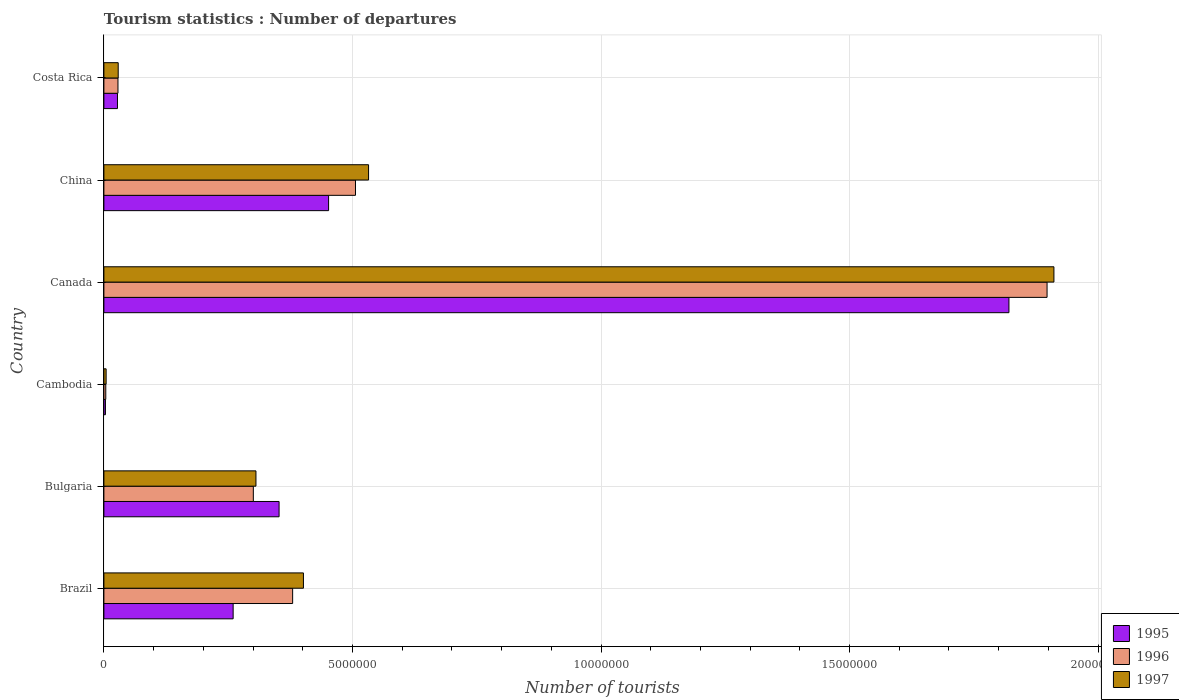How many bars are there on the 6th tick from the bottom?
Your answer should be compact. 3. What is the label of the 6th group of bars from the top?
Your answer should be very brief. Brazil. What is the number of tourist departures in 1995 in China?
Provide a succinct answer. 4.52e+06. Across all countries, what is the maximum number of tourist departures in 1996?
Give a very brief answer. 1.90e+07. Across all countries, what is the minimum number of tourist departures in 1996?
Your answer should be compact. 3.80e+04. In which country was the number of tourist departures in 1997 minimum?
Provide a succinct answer. Cambodia. What is the total number of tourist departures in 1995 in the graph?
Your answer should be very brief. 2.92e+07. What is the difference between the number of tourist departures in 1997 in Bulgaria and that in Cambodia?
Make the answer very short. 3.01e+06. What is the difference between the number of tourist departures in 1997 in Brazil and the number of tourist departures in 1996 in Bulgaria?
Offer a very short reply. 1.01e+06. What is the average number of tourist departures in 1995 per country?
Your answer should be very brief. 4.86e+06. What is the difference between the number of tourist departures in 1997 and number of tourist departures in 1996 in Cambodia?
Provide a short and direct response. 7000. What is the ratio of the number of tourist departures in 1996 in Brazil to that in Canada?
Your answer should be very brief. 0.2. Is the number of tourist departures in 1995 in Brazil less than that in Costa Rica?
Provide a succinct answer. No. What is the difference between the highest and the second highest number of tourist departures in 1997?
Give a very brief answer. 1.38e+07. What is the difference between the highest and the lowest number of tourist departures in 1997?
Your response must be concise. 1.91e+07. Is the sum of the number of tourist departures in 1995 in China and Costa Rica greater than the maximum number of tourist departures in 1997 across all countries?
Make the answer very short. No. What does the 3rd bar from the top in Brazil represents?
Make the answer very short. 1995. What does the 2nd bar from the bottom in Brazil represents?
Your answer should be very brief. 1996. Is it the case that in every country, the sum of the number of tourist departures in 1996 and number of tourist departures in 1995 is greater than the number of tourist departures in 1997?
Make the answer very short. Yes. How many bars are there?
Provide a short and direct response. 18. How many countries are there in the graph?
Provide a succinct answer. 6. What is the difference between two consecutive major ticks on the X-axis?
Provide a succinct answer. 5.00e+06. Are the values on the major ticks of X-axis written in scientific E-notation?
Keep it short and to the point. No. Does the graph contain any zero values?
Your answer should be compact. No. How many legend labels are there?
Keep it short and to the point. 3. What is the title of the graph?
Offer a terse response. Tourism statistics : Number of departures. What is the label or title of the X-axis?
Provide a short and direct response. Number of tourists. What is the label or title of the Y-axis?
Ensure brevity in your answer.  Country. What is the Number of tourists in 1995 in Brazil?
Keep it short and to the point. 2.60e+06. What is the Number of tourists of 1996 in Brazil?
Offer a terse response. 3.80e+06. What is the Number of tourists in 1997 in Brazil?
Your answer should be compact. 4.01e+06. What is the Number of tourists in 1995 in Bulgaria?
Your answer should be very brief. 3.52e+06. What is the Number of tourists of 1996 in Bulgaria?
Ensure brevity in your answer.  3.01e+06. What is the Number of tourists in 1997 in Bulgaria?
Offer a very short reply. 3.06e+06. What is the Number of tourists of 1995 in Cambodia?
Provide a short and direct response. 3.10e+04. What is the Number of tourists of 1996 in Cambodia?
Your answer should be compact. 3.80e+04. What is the Number of tourists in 1997 in Cambodia?
Your answer should be compact. 4.50e+04. What is the Number of tourists of 1995 in Canada?
Offer a very short reply. 1.82e+07. What is the Number of tourists in 1996 in Canada?
Your answer should be compact. 1.90e+07. What is the Number of tourists in 1997 in Canada?
Your answer should be compact. 1.91e+07. What is the Number of tourists of 1995 in China?
Your response must be concise. 4.52e+06. What is the Number of tourists of 1996 in China?
Provide a succinct answer. 5.06e+06. What is the Number of tourists in 1997 in China?
Provide a short and direct response. 5.32e+06. What is the Number of tourists in 1995 in Costa Rica?
Provide a short and direct response. 2.73e+05. What is the Number of tourists of 1996 in Costa Rica?
Your answer should be very brief. 2.83e+05. What is the Number of tourists of 1997 in Costa Rica?
Your response must be concise. 2.88e+05. Across all countries, what is the maximum Number of tourists of 1995?
Ensure brevity in your answer.  1.82e+07. Across all countries, what is the maximum Number of tourists of 1996?
Offer a terse response. 1.90e+07. Across all countries, what is the maximum Number of tourists of 1997?
Keep it short and to the point. 1.91e+07. Across all countries, what is the minimum Number of tourists of 1995?
Give a very brief answer. 3.10e+04. Across all countries, what is the minimum Number of tourists in 1996?
Your answer should be compact. 3.80e+04. Across all countries, what is the minimum Number of tourists of 1997?
Your answer should be compact. 4.50e+04. What is the total Number of tourists in 1995 in the graph?
Make the answer very short. 2.92e+07. What is the total Number of tourists of 1996 in the graph?
Offer a very short reply. 3.12e+07. What is the total Number of tourists of 1997 in the graph?
Ensure brevity in your answer.  3.18e+07. What is the difference between the Number of tourists of 1995 in Brazil and that in Bulgaria?
Offer a very short reply. -9.24e+05. What is the difference between the Number of tourists of 1996 in Brazil and that in Bulgaria?
Offer a terse response. 7.91e+05. What is the difference between the Number of tourists of 1997 in Brazil and that in Bulgaria?
Your answer should be compact. 9.55e+05. What is the difference between the Number of tourists of 1995 in Brazil and that in Cambodia?
Your response must be concise. 2.57e+06. What is the difference between the Number of tourists of 1996 in Brazil and that in Cambodia?
Offer a terse response. 3.76e+06. What is the difference between the Number of tourists in 1997 in Brazil and that in Cambodia?
Provide a short and direct response. 3.97e+06. What is the difference between the Number of tourists in 1995 in Brazil and that in Canada?
Give a very brief answer. -1.56e+07. What is the difference between the Number of tourists in 1996 in Brazil and that in Canada?
Make the answer very short. -1.52e+07. What is the difference between the Number of tourists in 1997 in Brazil and that in Canada?
Your answer should be compact. -1.51e+07. What is the difference between the Number of tourists of 1995 in Brazil and that in China?
Your response must be concise. -1.92e+06. What is the difference between the Number of tourists in 1996 in Brazil and that in China?
Your answer should be very brief. -1.26e+06. What is the difference between the Number of tourists in 1997 in Brazil and that in China?
Offer a very short reply. -1.31e+06. What is the difference between the Number of tourists of 1995 in Brazil and that in Costa Rica?
Keep it short and to the point. 2.33e+06. What is the difference between the Number of tourists in 1996 in Brazil and that in Costa Rica?
Your answer should be compact. 3.51e+06. What is the difference between the Number of tourists in 1997 in Brazil and that in Costa Rica?
Ensure brevity in your answer.  3.73e+06. What is the difference between the Number of tourists of 1995 in Bulgaria and that in Cambodia?
Offer a terse response. 3.49e+06. What is the difference between the Number of tourists of 1996 in Bulgaria and that in Cambodia?
Give a very brief answer. 2.97e+06. What is the difference between the Number of tourists in 1997 in Bulgaria and that in Cambodia?
Your answer should be very brief. 3.01e+06. What is the difference between the Number of tourists of 1995 in Bulgaria and that in Canada?
Provide a succinct answer. -1.47e+07. What is the difference between the Number of tourists of 1996 in Bulgaria and that in Canada?
Your answer should be very brief. -1.60e+07. What is the difference between the Number of tourists in 1997 in Bulgaria and that in Canada?
Your answer should be compact. -1.61e+07. What is the difference between the Number of tourists in 1995 in Bulgaria and that in China?
Keep it short and to the point. -9.96e+05. What is the difference between the Number of tourists in 1996 in Bulgaria and that in China?
Your answer should be very brief. -2.06e+06. What is the difference between the Number of tourists in 1997 in Bulgaria and that in China?
Keep it short and to the point. -2.26e+06. What is the difference between the Number of tourists of 1995 in Bulgaria and that in Costa Rica?
Give a very brief answer. 3.25e+06. What is the difference between the Number of tourists in 1996 in Bulgaria and that in Costa Rica?
Make the answer very short. 2.72e+06. What is the difference between the Number of tourists of 1997 in Bulgaria and that in Costa Rica?
Your answer should be compact. 2.77e+06. What is the difference between the Number of tourists of 1995 in Cambodia and that in Canada?
Provide a short and direct response. -1.82e+07. What is the difference between the Number of tourists of 1996 in Cambodia and that in Canada?
Provide a succinct answer. -1.89e+07. What is the difference between the Number of tourists of 1997 in Cambodia and that in Canada?
Provide a succinct answer. -1.91e+07. What is the difference between the Number of tourists in 1995 in Cambodia and that in China?
Your answer should be compact. -4.49e+06. What is the difference between the Number of tourists of 1996 in Cambodia and that in China?
Keep it short and to the point. -5.02e+06. What is the difference between the Number of tourists of 1997 in Cambodia and that in China?
Offer a very short reply. -5.28e+06. What is the difference between the Number of tourists of 1995 in Cambodia and that in Costa Rica?
Provide a succinct answer. -2.42e+05. What is the difference between the Number of tourists of 1996 in Cambodia and that in Costa Rica?
Keep it short and to the point. -2.45e+05. What is the difference between the Number of tourists in 1997 in Cambodia and that in Costa Rica?
Offer a very short reply. -2.43e+05. What is the difference between the Number of tourists in 1995 in Canada and that in China?
Provide a short and direct response. 1.37e+07. What is the difference between the Number of tourists in 1996 in Canada and that in China?
Give a very brief answer. 1.39e+07. What is the difference between the Number of tourists of 1997 in Canada and that in China?
Provide a succinct answer. 1.38e+07. What is the difference between the Number of tourists in 1995 in Canada and that in Costa Rica?
Your answer should be very brief. 1.79e+07. What is the difference between the Number of tourists in 1996 in Canada and that in Costa Rica?
Your response must be concise. 1.87e+07. What is the difference between the Number of tourists in 1997 in Canada and that in Costa Rica?
Make the answer very short. 1.88e+07. What is the difference between the Number of tourists in 1995 in China and that in Costa Rica?
Offer a terse response. 4.25e+06. What is the difference between the Number of tourists of 1996 in China and that in Costa Rica?
Offer a very short reply. 4.78e+06. What is the difference between the Number of tourists of 1997 in China and that in Costa Rica?
Your response must be concise. 5.04e+06. What is the difference between the Number of tourists of 1995 in Brazil and the Number of tourists of 1996 in Bulgaria?
Give a very brief answer. -4.06e+05. What is the difference between the Number of tourists of 1995 in Brazil and the Number of tourists of 1997 in Bulgaria?
Your answer should be very brief. -4.59e+05. What is the difference between the Number of tourists of 1996 in Brazil and the Number of tourists of 1997 in Bulgaria?
Provide a short and direct response. 7.38e+05. What is the difference between the Number of tourists of 1995 in Brazil and the Number of tourists of 1996 in Cambodia?
Ensure brevity in your answer.  2.56e+06. What is the difference between the Number of tourists in 1995 in Brazil and the Number of tourists in 1997 in Cambodia?
Your answer should be very brief. 2.56e+06. What is the difference between the Number of tourists of 1996 in Brazil and the Number of tourists of 1997 in Cambodia?
Provide a succinct answer. 3.75e+06. What is the difference between the Number of tourists in 1995 in Brazil and the Number of tourists in 1996 in Canada?
Your response must be concise. -1.64e+07. What is the difference between the Number of tourists in 1995 in Brazil and the Number of tourists in 1997 in Canada?
Ensure brevity in your answer.  -1.65e+07. What is the difference between the Number of tourists of 1996 in Brazil and the Number of tourists of 1997 in Canada?
Your response must be concise. -1.53e+07. What is the difference between the Number of tourists of 1995 in Brazil and the Number of tourists of 1996 in China?
Provide a succinct answer. -2.46e+06. What is the difference between the Number of tourists in 1995 in Brazil and the Number of tourists in 1997 in China?
Offer a terse response. -2.72e+06. What is the difference between the Number of tourists in 1996 in Brazil and the Number of tourists in 1997 in China?
Keep it short and to the point. -1.53e+06. What is the difference between the Number of tourists of 1995 in Brazil and the Number of tourists of 1996 in Costa Rica?
Make the answer very short. 2.32e+06. What is the difference between the Number of tourists of 1995 in Brazil and the Number of tourists of 1997 in Costa Rica?
Offer a terse response. 2.31e+06. What is the difference between the Number of tourists in 1996 in Brazil and the Number of tourists in 1997 in Costa Rica?
Keep it short and to the point. 3.51e+06. What is the difference between the Number of tourists of 1995 in Bulgaria and the Number of tourists of 1996 in Cambodia?
Give a very brief answer. 3.49e+06. What is the difference between the Number of tourists of 1995 in Bulgaria and the Number of tourists of 1997 in Cambodia?
Make the answer very short. 3.48e+06. What is the difference between the Number of tourists in 1996 in Bulgaria and the Number of tourists in 1997 in Cambodia?
Offer a very short reply. 2.96e+06. What is the difference between the Number of tourists of 1995 in Bulgaria and the Number of tourists of 1996 in Canada?
Provide a succinct answer. -1.54e+07. What is the difference between the Number of tourists in 1995 in Bulgaria and the Number of tourists in 1997 in Canada?
Keep it short and to the point. -1.56e+07. What is the difference between the Number of tourists of 1996 in Bulgaria and the Number of tourists of 1997 in Canada?
Offer a terse response. -1.61e+07. What is the difference between the Number of tourists of 1995 in Bulgaria and the Number of tourists of 1996 in China?
Keep it short and to the point. -1.54e+06. What is the difference between the Number of tourists in 1995 in Bulgaria and the Number of tourists in 1997 in China?
Provide a short and direct response. -1.80e+06. What is the difference between the Number of tourists of 1996 in Bulgaria and the Number of tourists of 1997 in China?
Provide a succinct answer. -2.32e+06. What is the difference between the Number of tourists of 1995 in Bulgaria and the Number of tourists of 1996 in Costa Rica?
Make the answer very short. 3.24e+06. What is the difference between the Number of tourists of 1995 in Bulgaria and the Number of tourists of 1997 in Costa Rica?
Ensure brevity in your answer.  3.24e+06. What is the difference between the Number of tourists in 1996 in Bulgaria and the Number of tourists in 1997 in Costa Rica?
Provide a succinct answer. 2.72e+06. What is the difference between the Number of tourists of 1995 in Cambodia and the Number of tourists of 1996 in Canada?
Provide a short and direct response. -1.89e+07. What is the difference between the Number of tourists of 1995 in Cambodia and the Number of tourists of 1997 in Canada?
Keep it short and to the point. -1.91e+07. What is the difference between the Number of tourists of 1996 in Cambodia and the Number of tourists of 1997 in Canada?
Provide a succinct answer. -1.91e+07. What is the difference between the Number of tourists in 1995 in Cambodia and the Number of tourists in 1996 in China?
Provide a short and direct response. -5.03e+06. What is the difference between the Number of tourists in 1995 in Cambodia and the Number of tourists in 1997 in China?
Keep it short and to the point. -5.29e+06. What is the difference between the Number of tourists of 1996 in Cambodia and the Number of tourists of 1997 in China?
Your answer should be very brief. -5.29e+06. What is the difference between the Number of tourists of 1995 in Cambodia and the Number of tourists of 1996 in Costa Rica?
Offer a terse response. -2.52e+05. What is the difference between the Number of tourists of 1995 in Cambodia and the Number of tourists of 1997 in Costa Rica?
Offer a very short reply. -2.57e+05. What is the difference between the Number of tourists in 1996 in Cambodia and the Number of tourists in 1997 in Costa Rica?
Ensure brevity in your answer.  -2.50e+05. What is the difference between the Number of tourists of 1995 in Canada and the Number of tourists of 1996 in China?
Your answer should be compact. 1.31e+07. What is the difference between the Number of tourists of 1995 in Canada and the Number of tourists of 1997 in China?
Ensure brevity in your answer.  1.29e+07. What is the difference between the Number of tourists in 1996 in Canada and the Number of tourists in 1997 in China?
Your answer should be compact. 1.36e+07. What is the difference between the Number of tourists of 1995 in Canada and the Number of tourists of 1996 in Costa Rica?
Keep it short and to the point. 1.79e+07. What is the difference between the Number of tourists in 1995 in Canada and the Number of tourists in 1997 in Costa Rica?
Your answer should be very brief. 1.79e+07. What is the difference between the Number of tourists of 1996 in Canada and the Number of tourists of 1997 in Costa Rica?
Your answer should be compact. 1.87e+07. What is the difference between the Number of tourists of 1995 in China and the Number of tourists of 1996 in Costa Rica?
Your answer should be compact. 4.24e+06. What is the difference between the Number of tourists of 1995 in China and the Number of tourists of 1997 in Costa Rica?
Your response must be concise. 4.23e+06. What is the difference between the Number of tourists in 1996 in China and the Number of tourists in 1997 in Costa Rica?
Make the answer very short. 4.77e+06. What is the average Number of tourists of 1995 per country?
Provide a succinct answer. 4.86e+06. What is the average Number of tourists in 1996 per country?
Offer a very short reply. 5.19e+06. What is the average Number of tourists in 1997 per country?
Your answer should be very brief. 5.31e+06. What is the difference between the Number of tourists in 1995 and Number of tourists in 1996 in Brazil?
Keep it short and to the point. -1.20e+06. What is the difference between the Number of tourists of 1995 and Number of tourists of 1997 in Brazil?
Your answer should be very brief. -1.41e+06. What is the difference between the Number of tourists in 1996 and Number of tourists in 1997 in Brazil?
Make the answer very short. -2.17e+05. What is the difference between the Number of tourists in 1995 and Number of tourists in 1996 in Bulgaria?
Your answer should be compact. 5.18e+05. What is the difference between the Number of tourists in 1995 and Number of tourists in 1997 in Bulgaria?
Give a very brief answer. 4.65e+05. What is the difference between the Number of tourists in 1996 and Number of tourists in 1997 in Bulgaria?
Make the answer very short. -5.30e+04. What is the difference between the Number of tourists in 1995 and Number of tourists in 1996 in Cambodia?
Offer a very short reply. -7000. What is the difference between the Number of tourists in 1995 and Number of tourists in 1997 in Cambodia?
Your answer should be very brief. -1.40e+04. What is the difference between the Number of tourists in 1996 and Number of tourists in 1997 in Cambodia?
Your answer should be very brief. -7000. What is the difference between the Number of tourists of 1995 and Number of tourists of 1996 in Canada?
Keep it short and to the point. -7.67e+05. What is the difference between the Number of tourists in 1995 and Number of tourists in 1997 in Canada?
Your response must be concise. -9.05e+05. What is the difference between the Number of tourists of 1996 and Number of tourists of 1997 in Canada?
Offer a very short reply. -1.38e+05. What is the difference between the Number of tourists in 1995 and Number of tourists in 1996 in China?
Provide a succinct answer. -5.41e+05. What is the difference between the Number of tourists in 1995 and Number of tourists in 1997 in China?
Provide a short and direct response. -8.04e+05. What is the difference between the Number of tourists of 1996 and Number of tourists of 1997 in China?
Your answer should be very brief. -2.63e+05. What is the difference between the Number of tourists in 1995 and Number of tourists in 1997 in Costa Rica?
Make the answer very short. -1.50e+04. What is the difference between the Number of tourists of 1996 and Number of tourists of 1997 in Costa Rica?
Your response must be concise. -5000. What is the ratio of the Number of tourists in 1995 in Brazil to that in Bulgaria?
Offer a very short reply. 0.74. What is the ratio of the Number of tourists of 1996 in Brazil to that in Bulgaria?
Your response must be concise. 1.26. What is the ratio of the Number of tourists of 1997 in Brazil to that in Bulgaria?
Offer a very short reply. 1.31. What is the ratio of the Number of tourists of 1995 in Brazil to that in Cambodia?
Offer a terse response. 83.87. What is the ratio of the Number of tourists of 1996 in Brazil to that in Cambodia?
Offer a terse response. 99.92. What is the ratio of the Number of tourists in 1997 in Brazil to that in Cambodia?
Offer a very short reply. 89.2. What is the ratio of the Number of tourists in 1995 in Brazil to that in Canada?
Give a very brief answer. 0.14. What is the ratio of the Number of tourists in 1996 in Brazil to that in Canada?
Your answer should be compact. 0.2. What is the ratio of the Number of tourists of 1997 in Brazil to that in Canada?
Make the answer very short. 0.21. What is the ratio of the Number of tourists of 1995 in Brazil to that in China?
Offer a very short reply. 0.58. What is the ratio of the Number of tourists in 1996 in Brazil to that in China?
Your answer should be compact. 0.75. What is the ratio of the Number of tourists in 1997 in Brazil to that in China?
Your answer should be compact. 0.75. What is the ratio of the Number of tourists of 1995 in Brazil to that in Costa Rica?
Provide a succinct answer. 9.52. What is the ratio of the Number of tourists of 1996 in Brazil to that in Costa Rica?
Offer a terse response. 13.42. What is the ratio of the Number of tourists in 1997 in Brazil to that in Costa Rica?
Offer a very short reply. 13.94. What is the ratio of the Number of tourists of 1995 in Bulgaria to that in Cambodia?
Offer a very short reply. 113.68. What is the ratio of the Number of tourists in 1996 in Bulgaria to that in Cambodia?
Offer a terse response. 79.11. What is the ratio of the Number of tourists in 1997 in Bulgaria to that in Cambodia?
Your answer should be compact. 67.98. What is the ratio of the Number of tourists in 1995 in Bulgaria to that in Canada?
Make the answer very short. 0.19. What is the ratio of the Number of tourists in 1996 in Bulgaria to that in Canada?
Give a very brief answer. 0.16. What is the ratio of the Number of tourists in 1997 in Bulgaria to that in Canada?
Ensure brevity in your answer.  0.16. What is the ratio of the Number of tourists in 1995 in Bulgaria to that in China?
Ensure brevity in your answer.  0.78. What is the ratio of the Number of tourists of 1996 in Bulgaria to that in China?
Provide a short and direct response. 0.59. What is the ratio of the Number of tourists of 1997 in Bulgaria to that in China?
Your response must be concise. 0.57. What is the ratio of the Number of tourists in 1995 in Bulgaria to that in Costa Rica?
Your response must be concise. 12.91. What is the ratio of the Number of tourists of 1996 in Bulgaria to that in Costa Rica?
Provide a short and direct response. 10.62. What is the ratio of the Number of tourists of 1997 in Bulgaria to that in Costa Rica?
Your answer should be compact. 10.62. What is the ratio of the Number of tourists in 1995 in Cambodia to that in Canada?
Ensure brevity in your answer.  0. What is the ratio of the Number of tourists in 1996 in Cambodia to that in Canada?
Keep it short and to the point. 0. What is the ratio of the Number of tourists of 1997 in Cambodia to that in Canada?
Make the answer very short. 0. What is the ratio of the Number of tourists of 1995 in Cambodia to that in China?
Your answer should be compact. 0.01. What is the ratio of the Number of tourists of 1996 in Cambodia to that in China?
Provide a succinct answer. 0.01. What is the ratio of the Number of tourists of 1997 in Cambodia to that in China?
Your response must be concise. 0.01. What is the ratio of the Number of tourists in 1995 in Cambodia to that in Costa Rica?
Your answer should be very brief. 0.11. What is the ratio of the Number of tourists of 1996 in Cambodia to that in Costa Rica?
Make the answer very short. 0.13. What is the ratio of the Number of tourists of 1997 in Cambodia to that in Costa Rica?
Your response must be concise. 0.16. What is the ratio of the Number of tourists of 1995 in Canada to that in China?
Provide a succinct answer. 4.03. What is the ratio of the Number of tourists in 1996 in Canada to that in China?
Make the answer very short. 3.75. What is the ratio of the Number of tourists in 1997 in Canada to that in China?
Ensure brevity in your answer.  3.59. What is the ratio of the Number of tourists of 1995 in Canada to that in Costa Rica?
Your answer should be very brief. 66.69. What is the ratio of the Number of tourists of 1996 in Canada to that in Costa Rica?
Offer a very short reply. 67.04. What is the ratio of the Number of tourists in 1997 in Canada to that in Costa Rica?
Give a very brief answer. 66.36. What is the ratio of the Number of tourists of 1995 in China to that in Costa Rica?
Offer a terse response. 16.56. What is the ratio of the Number of tourists of 1996 in China to that in Costa Rica?
Provide a succinct answer. 17.88. What is the ratio of the Number of tourists of 1997 in China to that in Costa Rica?
Give a very brief answer. 18.49. What is the difference between the highest and the second highest Number of tourists in 1995?
Make the answer very short. 1.37e+07. What is the difference between the highest and the second highest Number of tourists in 1996?
Offer a very short reply. 1.39e+07. What is the difference between the highest and the second highest Number of tourists in 1997?
Provide a succinct answer. 1.38e+07. What is the difference between the highest and the lowest Number of tourists of 1995?
Your answer should be compact. 1.82e+07. What is the difference between the highest and the lowest Number of tourists of 1996?
Provide a succinct answer. 1.89e+07. What is the difference between the highest and the lowest Number of tourists of 1997?
Offer a very short reply. 1.91e+07. 